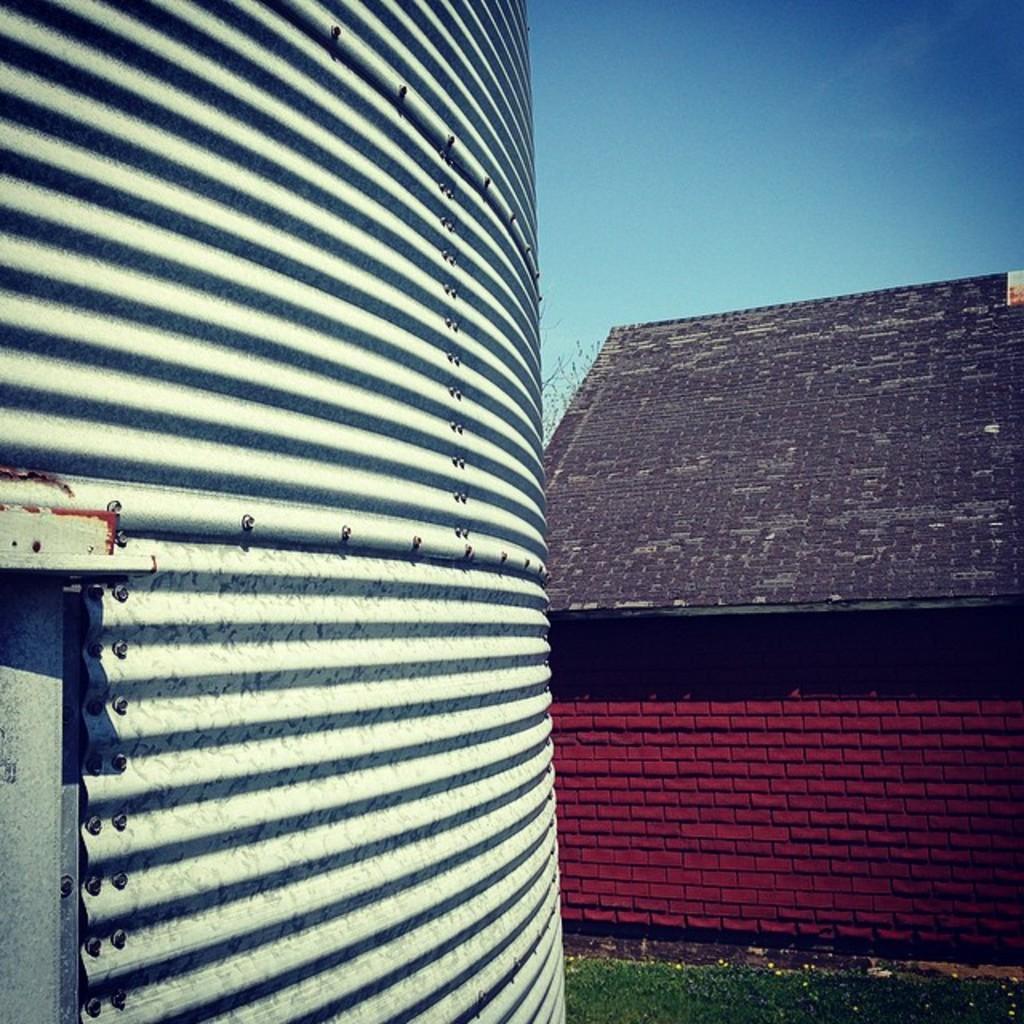Describe this image in one or two sentences. On this left side there is a surface, in the background there is a house and the sky. 